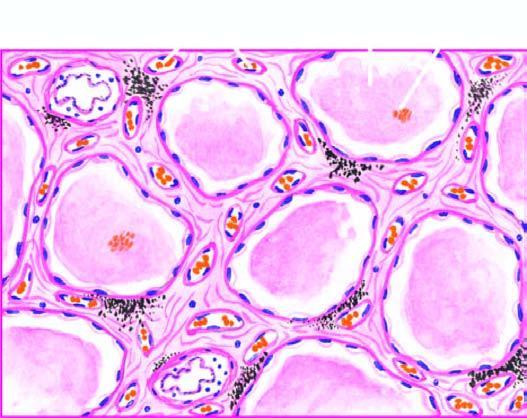what are congested?
Answer the question using a single word or phrase. The alveolar capillaries 